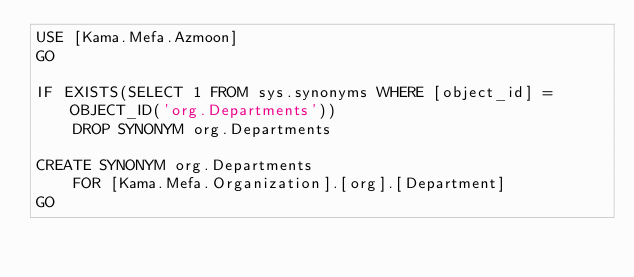<code> <loc_0><loc_0><loc_500><loc_500><_SQL_>USE [Kama.Mefa.Azmoon]
GO

IF EXISTS(SELECT 1 FROM sys.synonyms WHERE [object_id] = OBJECT_ID('org.Departments'))
	DROP SYNONYM org.Departments

CREATE SYNONYM org.Departments
	FOR [Kama.Mefa.Organization].[org].[Department]
GO</code> 